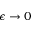<formula> <loc_0><loc_0><loc_500><loc_500>\epsilon \rightarrow 0</formula> 